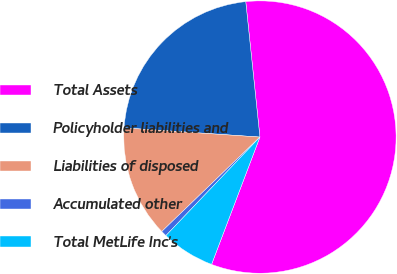Convert chart. <chart><loc_0><loc_0><loc_500><loc_500><pie_chart><fcel>Total Assets<fcel>Policyholder liabilities and<fcel>Liabilities of disposed<fcel>Accumulated other<fcel>Total MetLife Inc's<nl><fcel>57.44%<fcel>22.27%<fcel>13.27%<fcel>0.68%<fcel>6.35%<nl></chart> 